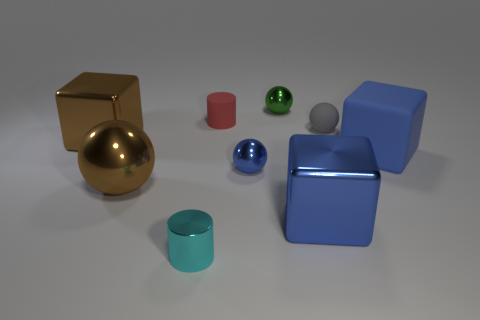Are there an equal number of balls to the right of the green ball and shiny things on the left side of the tiny cyan cylinder? Upon closer examination of the image, the answer is no. To the right of the green ball, there are two balls—a grey one and a blue one—while on the left side of the tiny cyan cylinder, there are a gold sphere and two boxes, which could be considered as shiny objects. Therefore, the shiny objects on the left of the cyan cylinder outnumber the balls on the right of the green ball. 